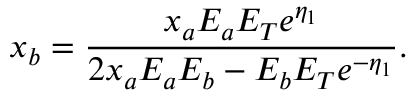Convert formula to latex. <formula><loc_0><loc_0><loc_500><loc_500>x _ { b } = \frac { x _ { a } E _ { a } E _ { T } e ^ { \eta _ { 1 } } } { 2 x _ { a } E _ { a } E _ { b } - E _ { b } E _ { T } e ^ { - \eta _ { 1 } } } .</formula> 